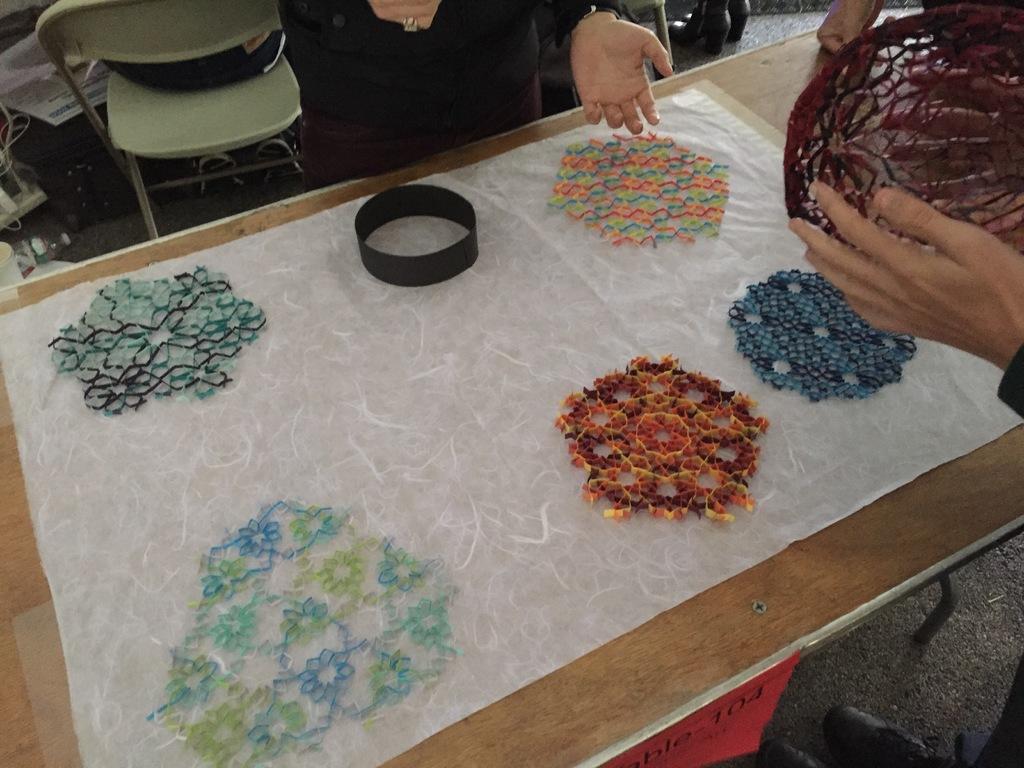Can you describe this image briefly? In this picture we can see few designs on the cloth, and the cloth is on the table, and we can see few people, a chair and a bottle. 